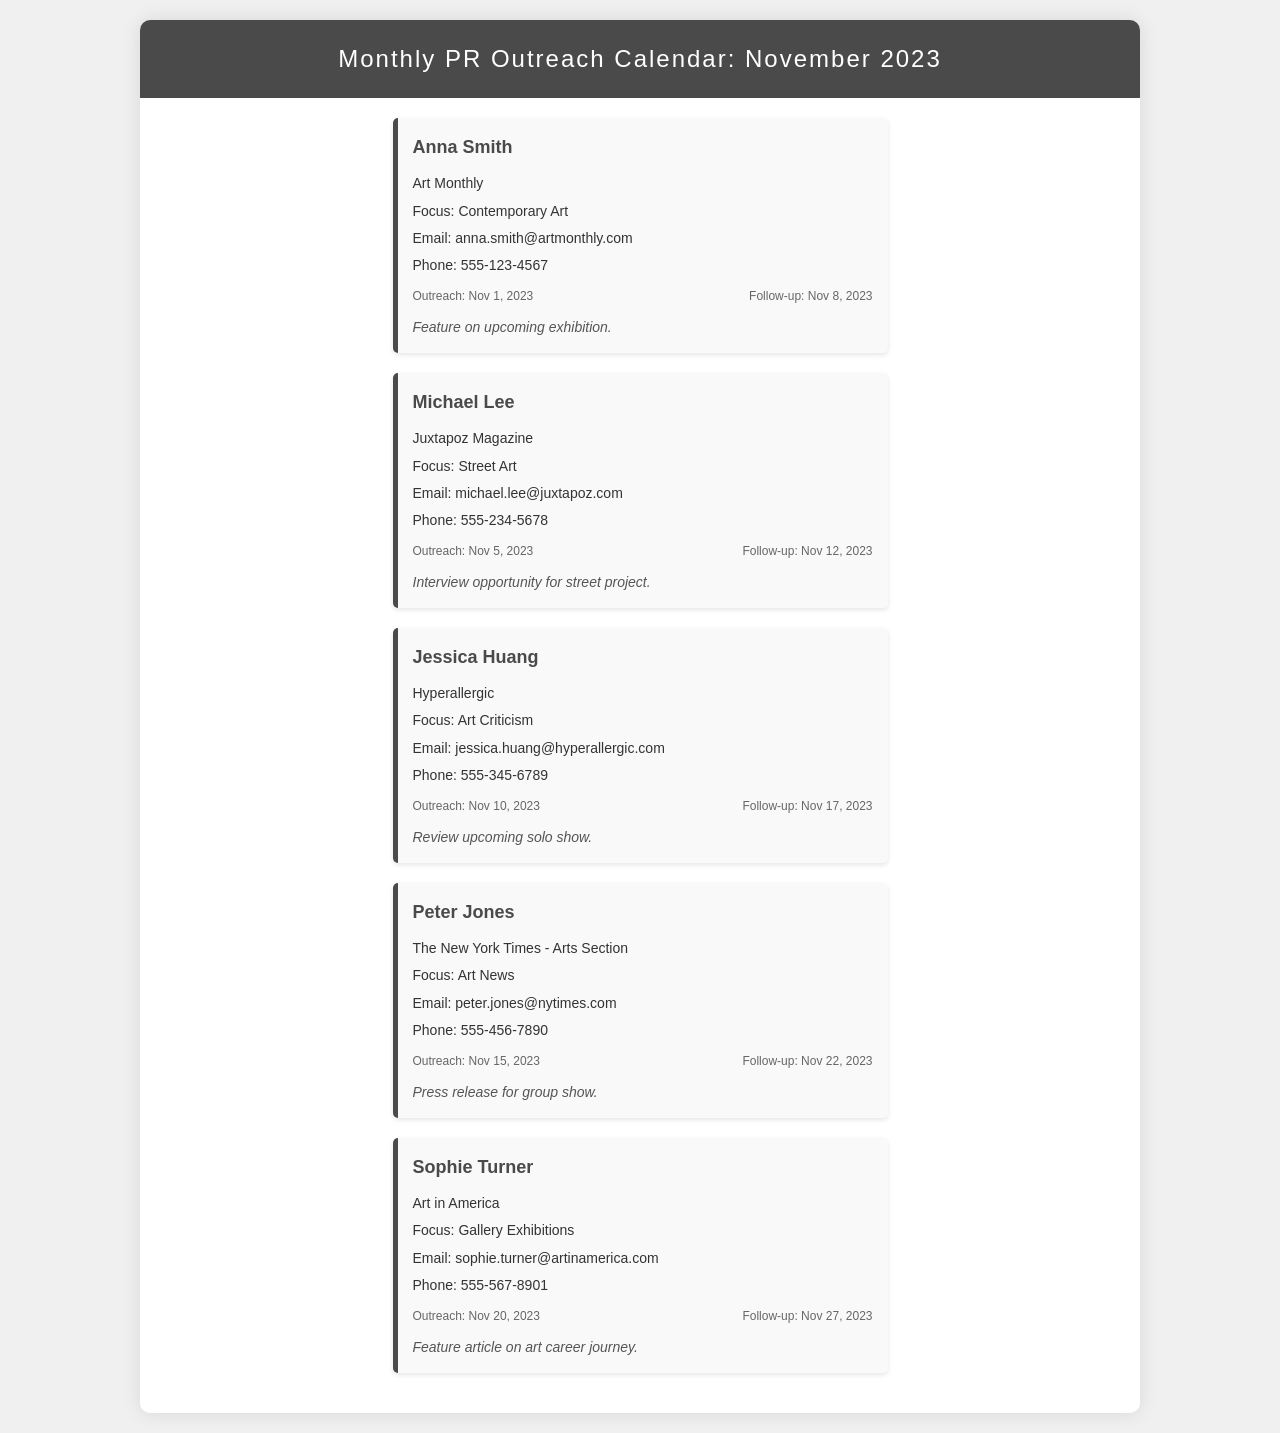what is the name of the first contact? The first contact listed in the document is Anna Smith.
Answer: Anna Smith what is the outreach date for Michael Lee? The outreach date for Michael Lee is specified in the document as Nov 5, 2023.
Answer: Nov 5, 2023 how many days after outreach is the follow-up for Jessica Huang? The follow-up for Jessica Huang is on Nov 17, 2023, which is 7 days after the outreach date on Nov 10, 2023.
Answer: 7 days which publication does Peter Jones represent? The document states that Peter Jones represents The New York Times - Arts Section.
Answer: The New York Times - Arts Section how many contacts are listed in the document? The document lists a total of five contacts.
Answer: five what is the focus area of Sophie Turner? The focus area of Sophie Turner is described as Gallery Exhibitions.
Answer: Gallery Exhibitions what is the follow-up date for Anna Smith? The follow-up date for Anna Smith is Nov 8, 2023.
Answer: Nov 8, 2023 who is scheduled for outreach on Nov 20, 2023? The document indicates that Sophie Turner is scheduled for outreach on Nov 20, 2023.
Answer: Sophie Turner what type of article is requested for Michael Lee? The document notes that an interview opportunity is requested for Michael Lee for a street project.
Answer: Interview opportunity for street project 